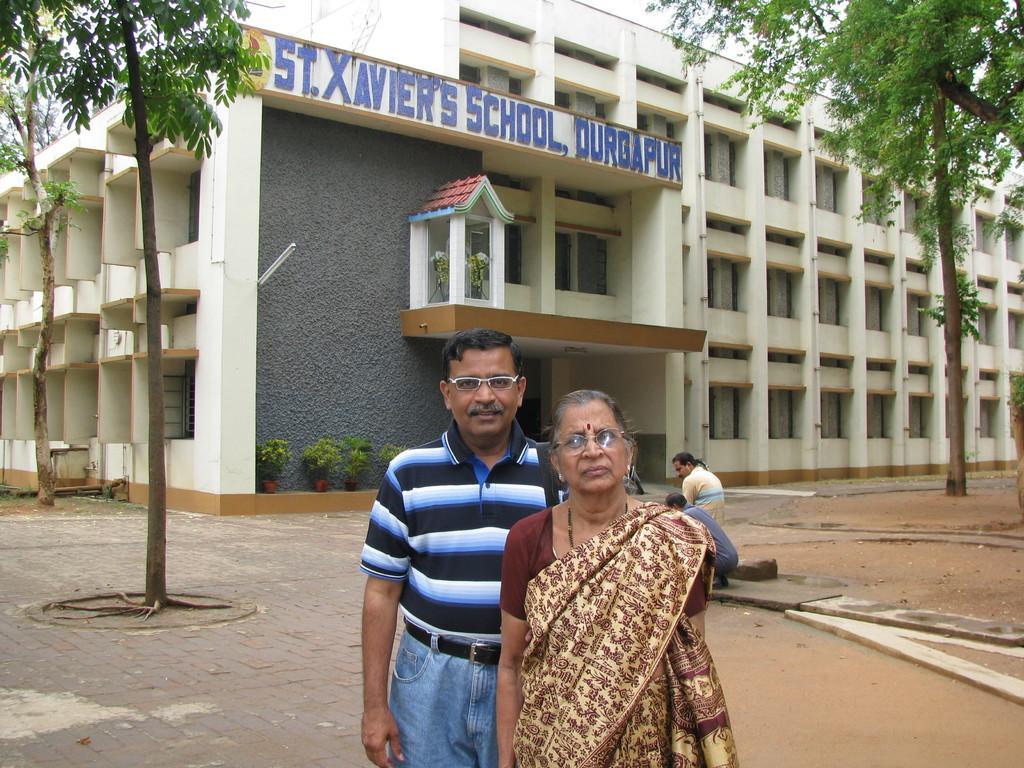Describe this image in one or two sentences. In the foreground of this image, there is a couple standing. Behind them, there are few trees, two men and a school on which there is some text names as ¨ST XAVIER'S SCHOOL, DURGAPUR¨. We can also see few plants and the sky. 